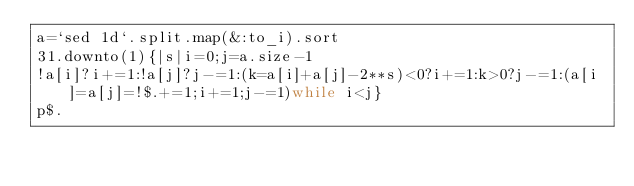Convert code to text. <code><loc_0><loc_0><loc_500><loc_500><_Ruby_>a=`sed 1d`.split.map(&:to_i).sort
31.downto(1){|s|i=0;j=a.size-1
!a[i]?i+=1:!a[j]?j-=1:(k=a[i]+a[j]-2**s)<0?i+=1:k>0?j-=1:(a[i]=a[j]=!$.+=1;i+=1;j-=1)while i<j}
p$.</code> 